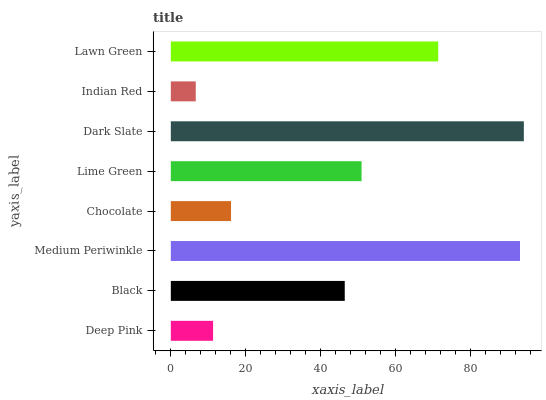Is Indian Red the minimum?
Answer yes or no. Yes. Is Dark Slate the maximum?
Answer yes or no. Yes. Is Black the minimum?
Answer yes or no. No. Is Black the maximum?
Answer yes or no. No. Is Black greater than Deep Pink?
Answer yes or no. Yes. Is Deep Pink less than Black?
Answer yes or no. Yes. Is Deep Pink greater than Black?
Answer yes or no. No. Is Black less than Deep Pink?
Answer yes or no. No. Is Lime Green the high median?
Answer yes or no. Yes. Is Black the low median?
Answer yes or no. Yes. Is Chocolate the high median?
Answer yes or no. No. Is Lawn Green the low median?
Answer yes or no. No. 